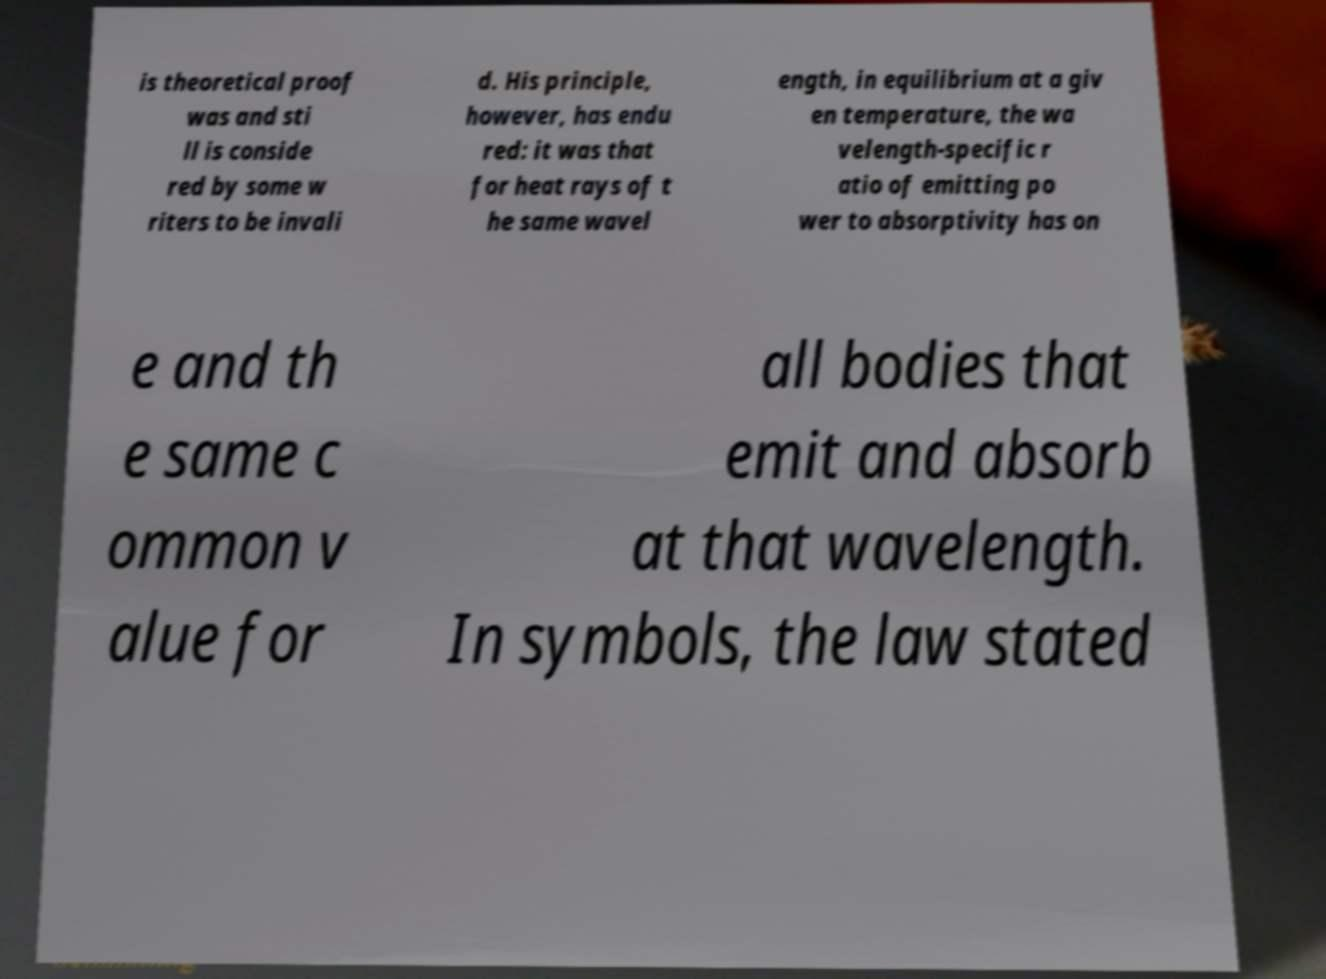Can you accurately transcribe the text from the provided image for me? is theoretical proof was and sti ll is conside red by some w riters to be invali d. His principle, however, has endu red: it was that for heat rays of t he same wavel ength, in equilibrium at a giv en temperature, the wa velength-specific r atio of emitting po wer to absorptivity has on e and th e same c ommon v alue for all bodies that emit and absorb at that wavelength. In symbols, the law stated 